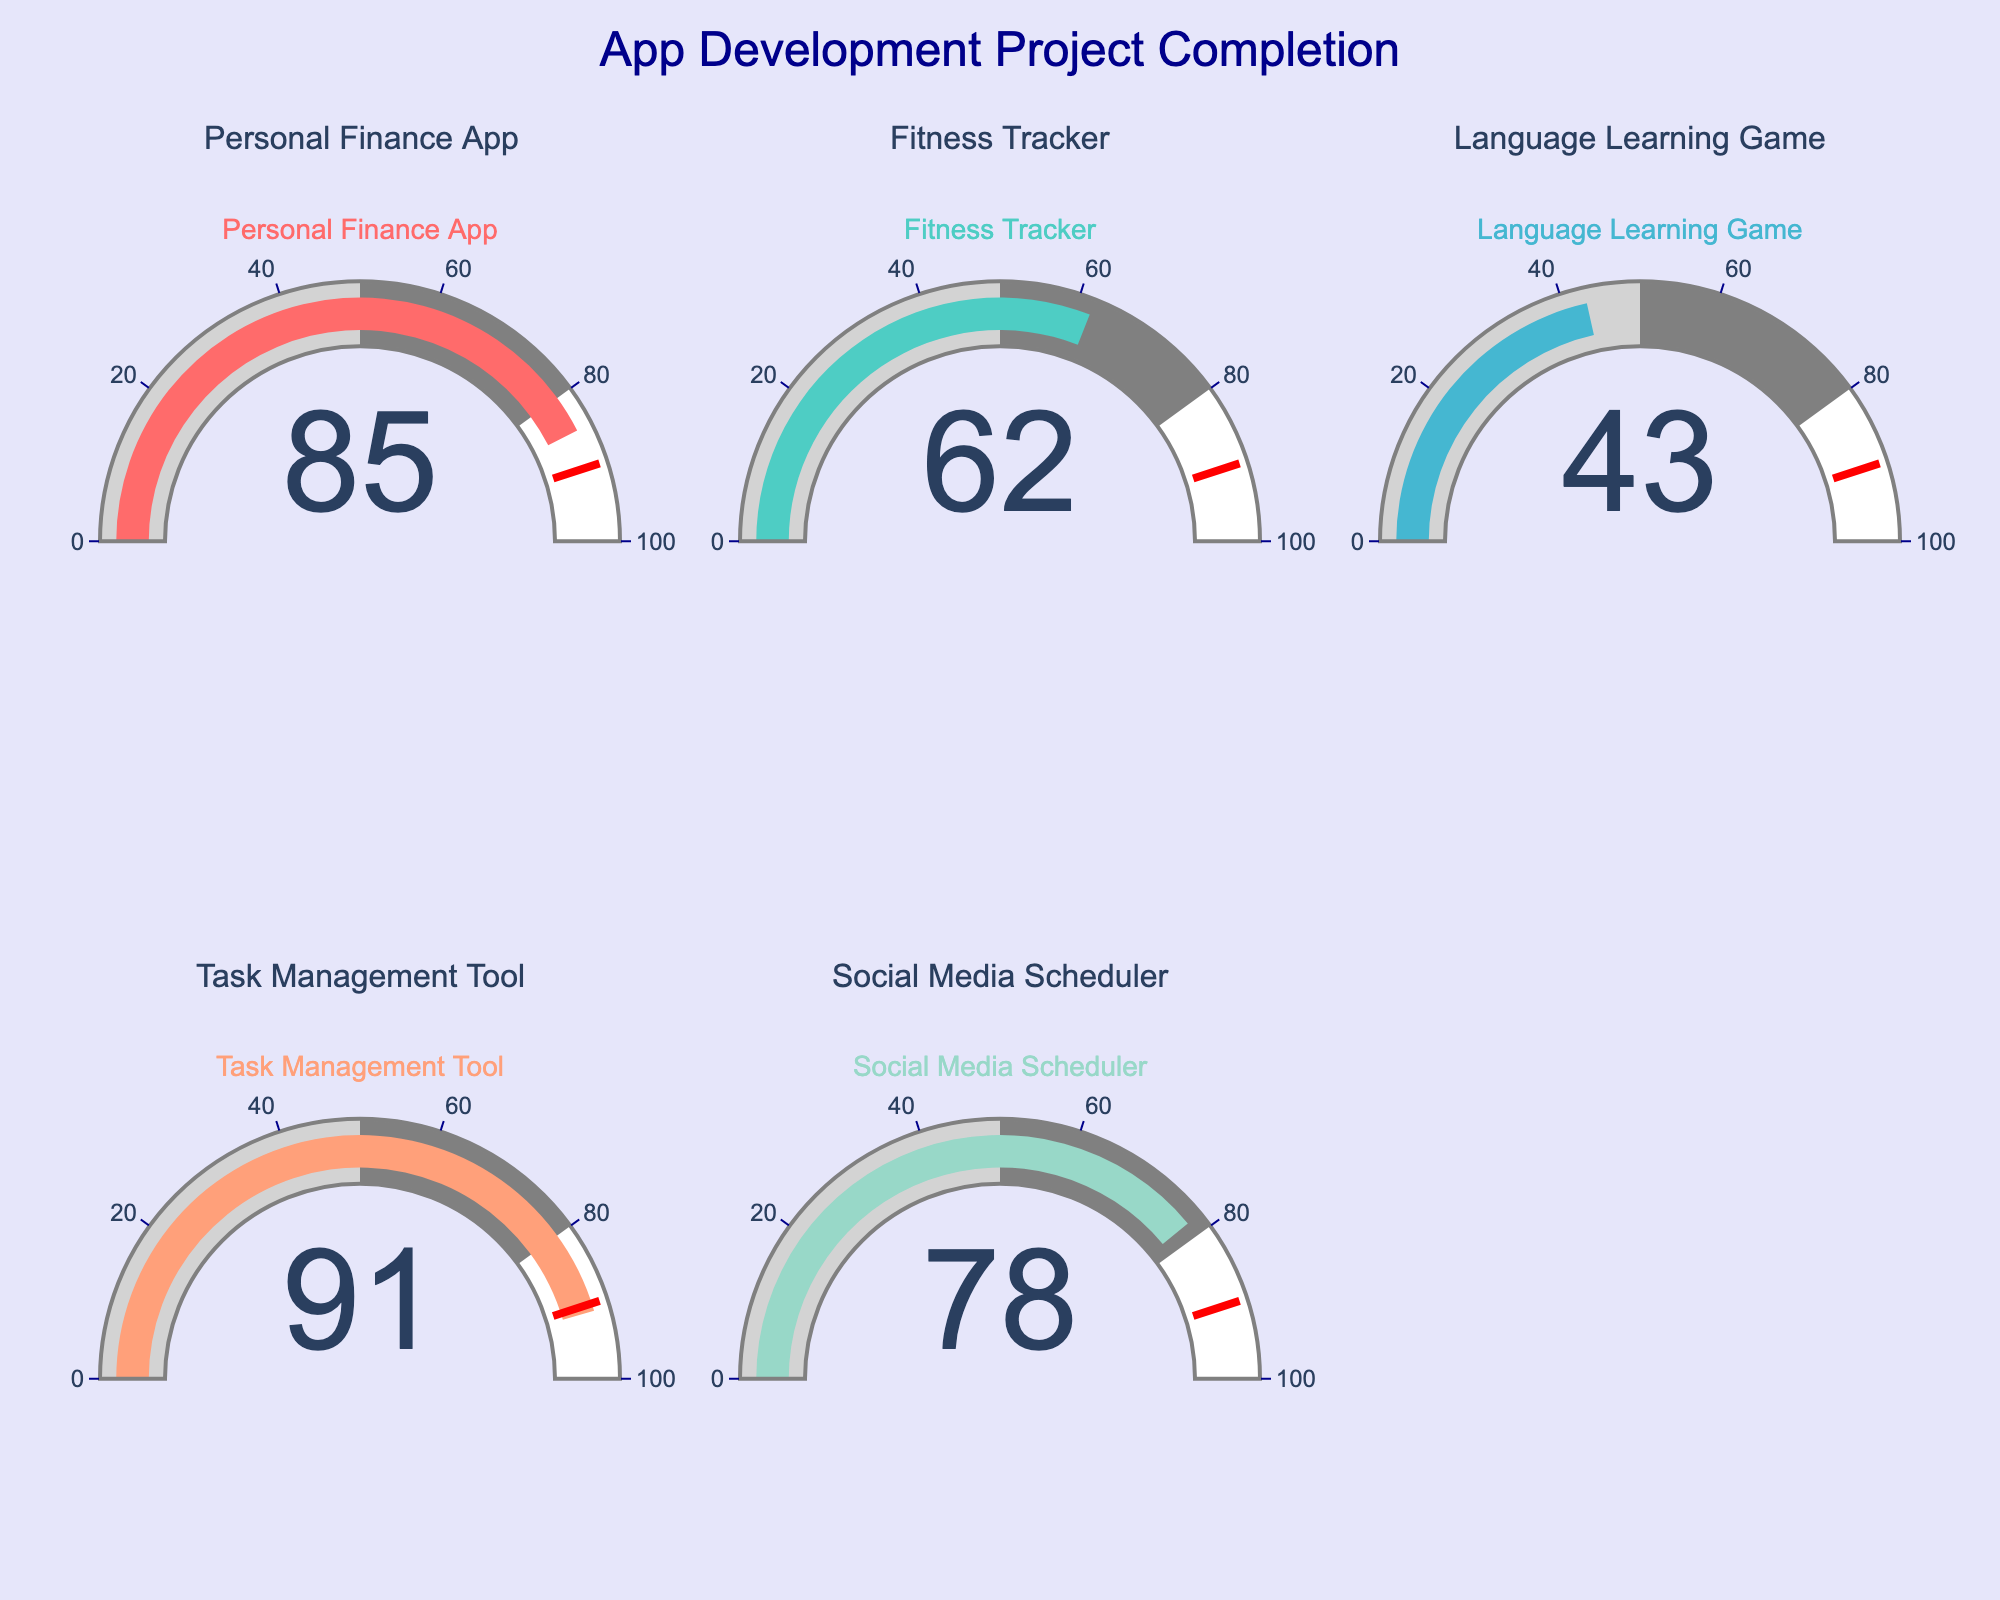What is the completion percentage for the Personal Finance App? The completion percentage for the Personal Finance App can be directly read from its gauge.
Answer: 85% Which app has the highest completion percentage? By comparing the completion percentages of all the apps displayed on the gauges, the Task Management Tool has the highest percentage.
Answer: Task Management Tool What is the average completion percentage of all the projects? Sum the completion percentages (85 + 62 + 43 + 91 + 78) which equals 359, then divide by the number of projects, 5. 359/5 equals 71.8
Answer: 71.8% Is the Social Media Scheduler more or less complete than the Fitness Tracker? Comparing the gauges, the Social Media Scheduler is at 78% while the Fitness Tracker is at 62%. Thus, the Social Media Scheduler is more complete.
Answer: More complete How many apps have a completion percentage above 75%? From the gauge chart: Personal Finance App (85%), Task Management Tool (91%), and Social Media Scheduler (78%) all have values above 75%. This makes 3 apps in total.
Answer: 3 What is the difference in completion percentage between the Language Learning Game and Task Management Tool? The Task Management Tool is at 91%, and the Language Learning Game is at 43%. The difference is 91 - 43 which equals 48.
Answer: 48% Which project is nearest to the completion threshold of 90%? By checking the gauges, the Task Management Tool is at 91%, which is the closest to 90%.
Answer: Task Management Tool What colors are used for the bars in the gauges? The colors for the bars in the gauges from left to right and top to bottom are: #FF6B6B (reddish), #4ECDC4 (greenish), #45B7D1 (bluish), #FFA07A (salmon), #98D8C8 (light green).
Answer: #FF6B6B, #4ECDC4, #45B7D1, #FFA07A, #98D8C8 